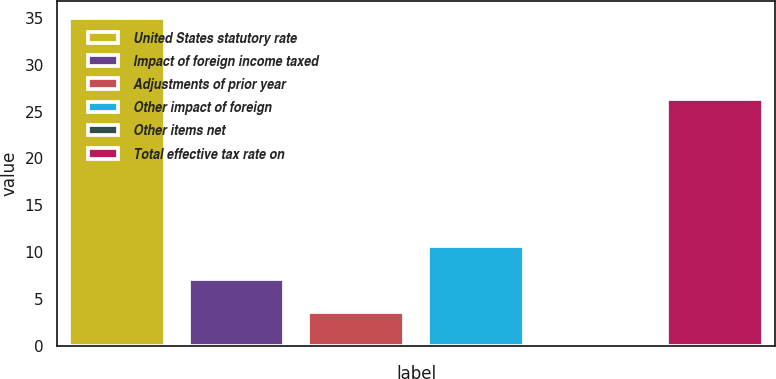Convert chart to OTSL. <chart><loc_0><loc_0><loc_500><loc_500><bar_chart><fcel>United States statutory rate<fcel>Impact of foreign income taxed<fcel>Adjustments of prior year<fcel>Other impact of foreign<fcel>Other items net<fcel>Total effective tax rate on<nl><fcel>35<fcel>7.16<fcel>3.68<fcel>10.64<fcel>0.2<fcel>26.3<nl></chart> 